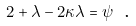Convert formula to latex. <formula><loc_0><loc_0><loc_500><loc_500>2 + \lambda - 2 \kappa \lambda = \psi \text { .}</formula> 